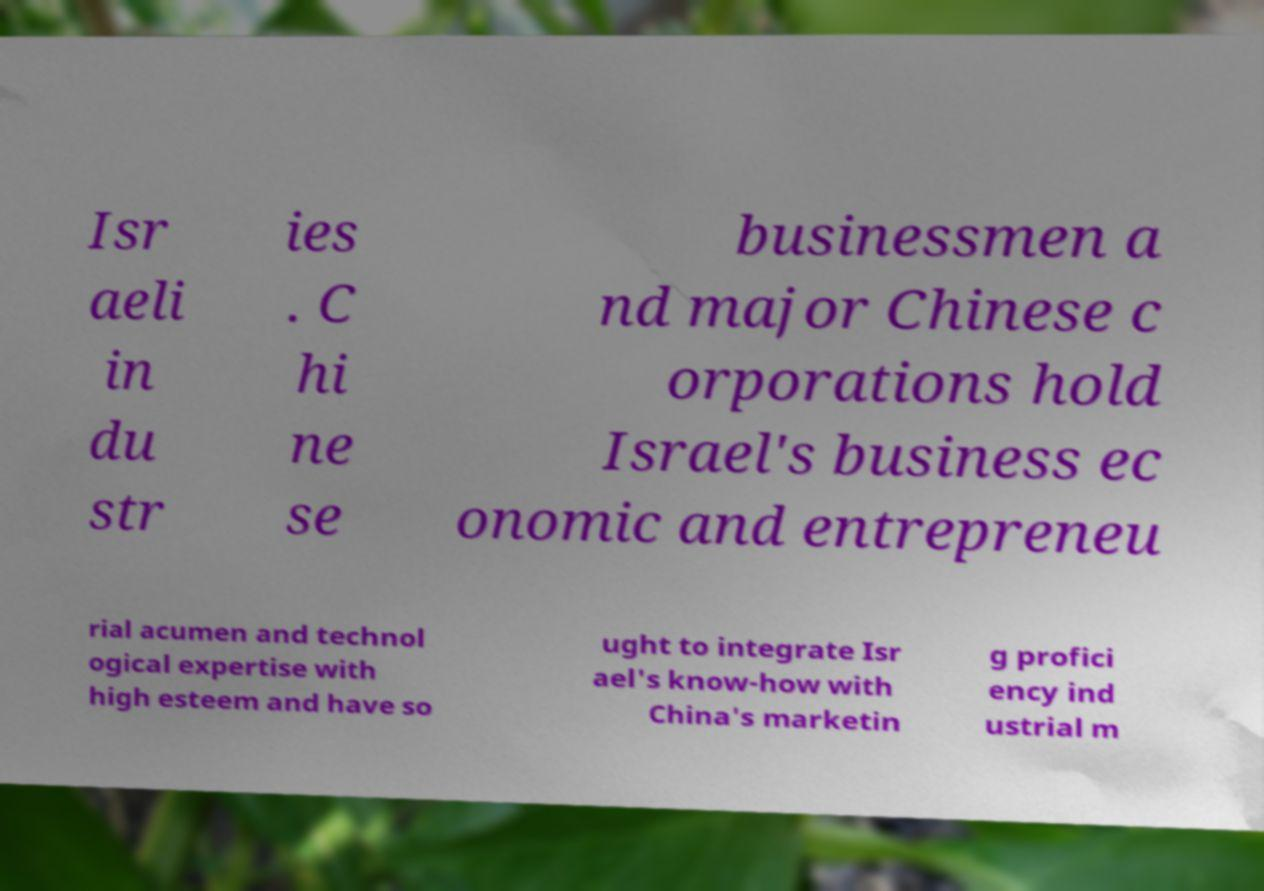Can you read and provide the text displayed in the image?This photo seems to have some interesting text. Can you extract and type it out for me? Isr aeli in du str ies . C hi ne se businessmen a nd major Chinese c orporations hold Israel's business ec onomic and entrepreneu rial acumen and technol ogical expertise with high esteem and have so ught to integrate Isr ael's know-how with China's marketin g profici ency ind ustrial m 